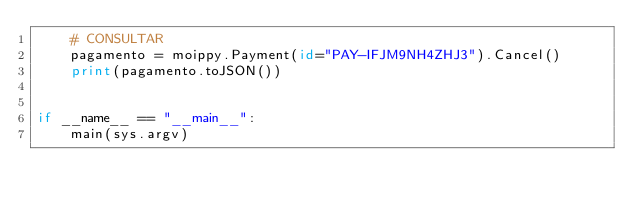<code> <loc_0><loc_0><loc_500><loc_500><_Python_>    # CONSULTAR
    pagamento = moippy.Payment(id="PAY-IFJM9NH4ZHJ3").Cancel()
    print(pagamento.toJSON())


if __name__ == "__main__":
    main(sys.argv)
</code> 